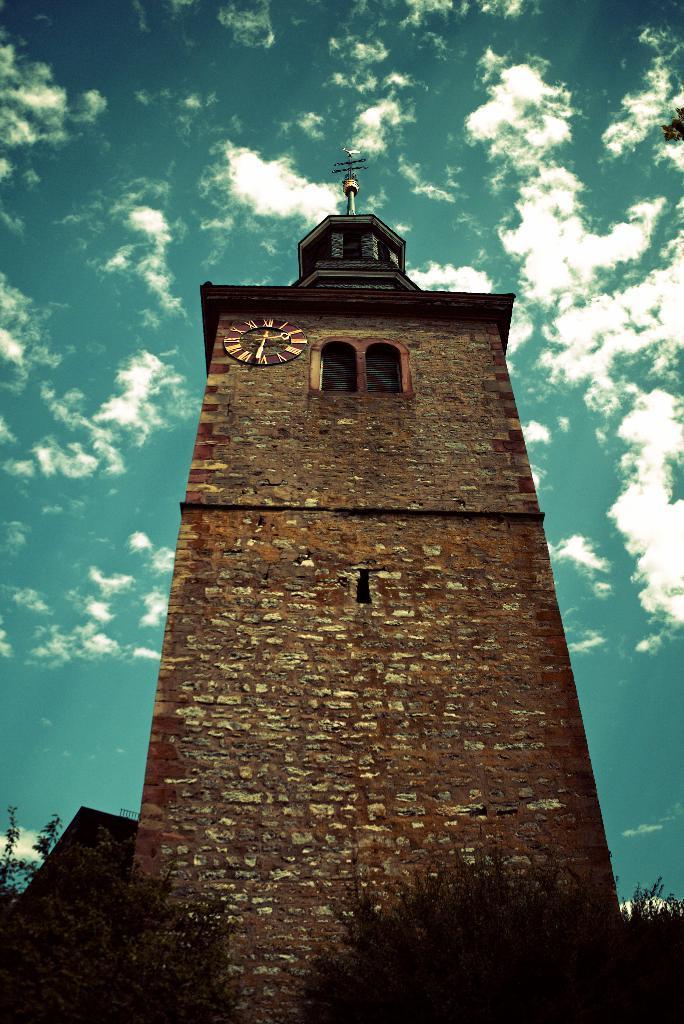Can you describe this image briefly? In the center of the image there is a brick structure. At the bottom of the image there are trees. In the background of the image there is sky. 